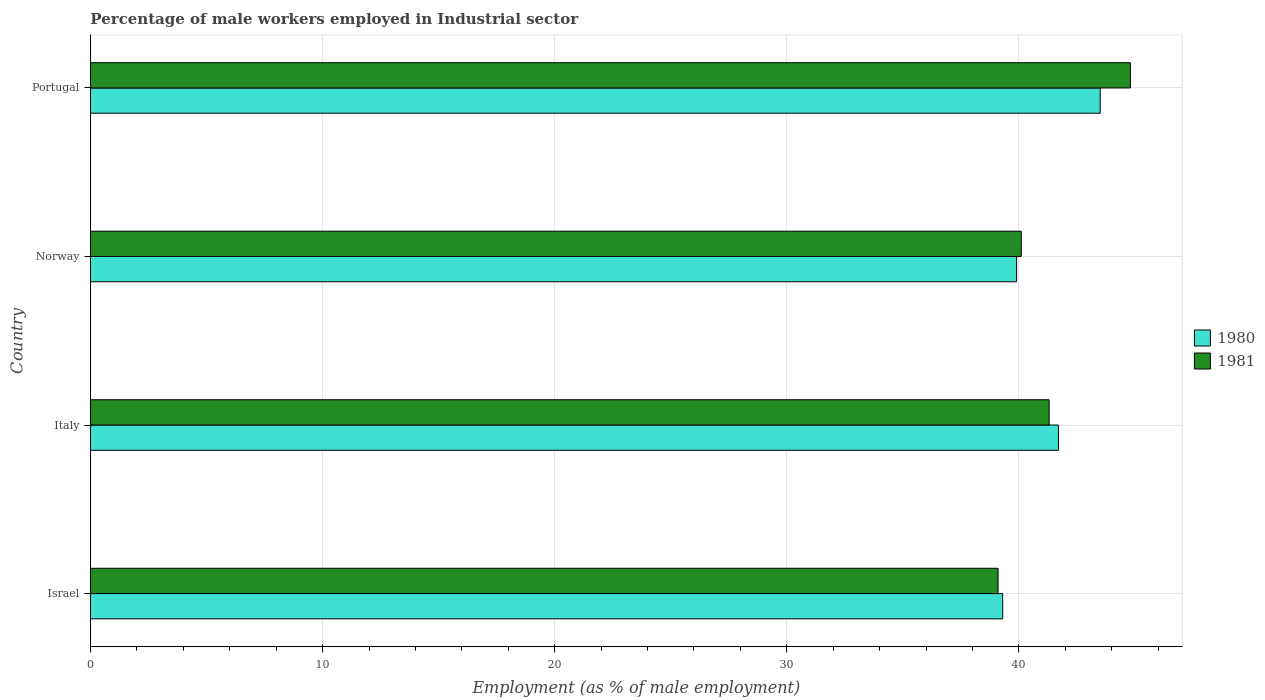What is the label of the 3rd group of bars from the top?
Provide a succinct answer. Italy. What is the percentage of male workers employed in Industrial sector in 1980 in Italy?
Provide a short and direct response. 41.7. Across all countries, what is the maximum percentage of male workers employed in Industrial sector in 1980?
Your response must be concise. 43.5. Across all countries, what is the minimum percentage of male workers employed in Industrial sector in 1980?
Provide a succinct answer. 39.3. What is the total percentage of male workers employed in Industrial sector in 1981 in the graph?
Offer a terse response. 165.3. What is the difference between the percentage of male workers employed in Industrial sector in 1980 in Israel and the percentage of male workers employed in Industrial sector in 1981 in Norway?
Your answer should be very brief. -0.8. What is the average percentage of male workers employed in Industrial sector in 1981 per country?
Your answer should be very brief. 41.32. What is the difference between the percentage of male workers employed in Industrial sector in 1981 and percentage of male workers employed in Industrial sector in 1980 in Norway?
Offer a terse response. 0.2. What is the ratio of the percentage of male workers employed in Industrial sector in 1981 in Italy to that in Norway?
Provide a short and direct response. 1.03. Is the difference between the percentage of male workers employed in Industrial sector in 1981 in Israel and Italy greater than the difference between the percentage of male workers employed in Industrial sector in 1980 in Israel and Italy?
Ensure brevity in your answer.  Yes. What is the difference between the highest and the second highest percentage of male workers employed in Industrial sector in 1980?
Provide a succinct answer. 1.8. What is the difference between the highest and the lowest percentage of male workers employed in Industrial sector in 1980?
Ensure brevity in your answer.  4.2. What does the 1st bar from the top in Norway represents?
Make the answer very short. 1981. What does the 2nd bar from the bottom in Italy represents?
Keep it short and to the point. 1981. What is the difference between two consecutive major ticks on the X-axis?
Provide a succinct answer. 10. Does the graph contain grids?
Your answer should be compact. Yes. Where does the legend appear in the graph?
Offer a terse response. Center right. How many legend labels are there?
Offer a very short reply. 2. What is the title of the graph?
Your answer should be very brief. Percentage of male workers employed in Industrial sector. What is the label or title of the X-axis?
Provide a short and direct response. Employment (as % of male employment). What is the Employment (as % of male employment) in 1980 in Israel?
Ensure brevity in your answer.  39.3. What is the Employment (as % of male employment) in 1981 in Israel?
Your answer should be very brief. 39.1. What is the Employment (as % of male employment) in 1980 in Italy?
Your answer should be compact. 41.7. What is the Employment (as % of male employment) of 1981 in Italy?
Offer a terse response. 41.3. What is the Employment (as % of male employment) in 1980 in Norway?
Make the answer very short. 39.9. What is the Employment (as % of male employment) in 1981 in Norway?
Your answer should be very brief. 40.1. What is the Employment (as % of male employment) of 1980 in Portugal?
Provide a succinct answer. 43.5. What is the Employment (as % of male employment) of 1981 in Portugal?
Your response must be concise. 44.8. Across all countries, what is the maximum Employment (as % of male employment) of 1980?
Provide a succinct answer. 43.5. Across all countries, what is the maximum Employment (as % of male employment) of 1981?
Offer a very short reply. 44.8. Across all countries, what is the minimum Employment (as % of male employment) in 1980?
Your response must be concise. 39.3. Across all countries, what is the minimum Employment (as % of male employment) of 1981?
Offer a very short reply. 39.1. What is the total Employment (as % of male employment) in 1980 in the graph?
Offer a terse response. 164.4. What is the total Employment (as % of male employment) in 1981 in the graph?
Ensure brevity in your answer.  165.3. What is the difference between the Employment (as % of male employment) of 1981 in Israel and that in Italy?
Provide a succinct answer. -2.2. What is the difference between the Employment (as % of male employment) of 1980 in Israel and that in Norway?
Ensure brevity in your answer.  -0.6. What is the difference between the Employment (as % of male employment) in 1980 in Italy and that in Portugal?
Ensure brevity in your answer.  -1.8. What is the difference between the Employment (as % of male employment) of 1981 in Italy and that in Portugal?
Your answer should be very brief. -3.5. What is the difference between the Employment (as % of male employment) in 1980 in Norway and that in Portugal?
Make the answer very short. -3.6. What is the difference between the Employment (as % of male employment) in 1981 in Norway and that in Portugal?
Give a very brief answer. -4.7. What is the difference between the Employment (as % of male employment) in 1980 in Israel and the Employment (as % of male employment) in 1981 in Italy?
Provide a short and direct response. -2. What is the difference between the Employment (as % of male employment) in 1980 in Israel and the Employment (as % of male employment) in 1981 in Norway?
Make the answer very short. -0.8. What is the difference between the Employment (as % of male employment) of 1980 in Israel and the Employment (as % of male employment) of 1981 in Portugal?
Ensure brevity in your answer.  -5.5. What is the average Employment (as % of male employment) in 1980 per country?
Your answer should be compact. 41.1. What is the average Employment (as % of male employment) of 1981 per country?
Provide a succinct answer. 41.33. What is the difference between the Employment (as % of male employment) in 1980 and Employment (as % of male employment) in 1981 in Norway?
Your response must be concise. -0.2. What is the ratio of the Employment (as % of male employment) in 1980 in Israel to that in Italy?
Offer a very short reply. 0.94. What is the ratio of the Employment (as % of male employment) of 1981 in Israel to that in Italy?
Make the answer very short. 0.95. What is the ratio of the Employment (as % of male employment) of 1980 in Israel to that in Norway?
Keep it short and to the point. 0.98. What is the ratio of the Employment (as % of male employment) of 1981 in Israel to that in Norway?
Give a very brief answer. 0.98. What is the ratio of the Employment (as % of male employment) in 1980 in Israel to that in Portugal?
Offer a terse response. 0.9. What is the ratio of the Employment (as % of male employment) of 1981 in Israel to that in Portugal?
Provide a short and direct response. 0.87. What is the ratio of the Employment (as % of male employment) of 1980 in Italy to that in Norway?
Give a very brief answer. 1.05. What is the ratio of the Employment (as % of male employment) of 1981 in Italy to that in Norway?
Give a very brief answer. 1.03. What is the ratio of the Employment (as % of male employment) in 1980 in Italy to that in Portugal?
Your response must be concise. 0.96. What is the ratio of the Employment (as % of male employment) of 1981 in Italy to that in Portugal?
Offer a terse response. 0.92. What is the ratio of the Employment (as % of male employment) in 1980 in Norway to that in Portugal?
Ensure brevity in your answer.  0.92. What is the ratio of the Employment (as % of male employment) of 1981 in Norway to that in Portugal?
Provide a succinct answer. 0.9. What is the difference between the highest and the second highest Employment (as % of male employment) in 1981?
Keep it short and to the point. 3.5. 